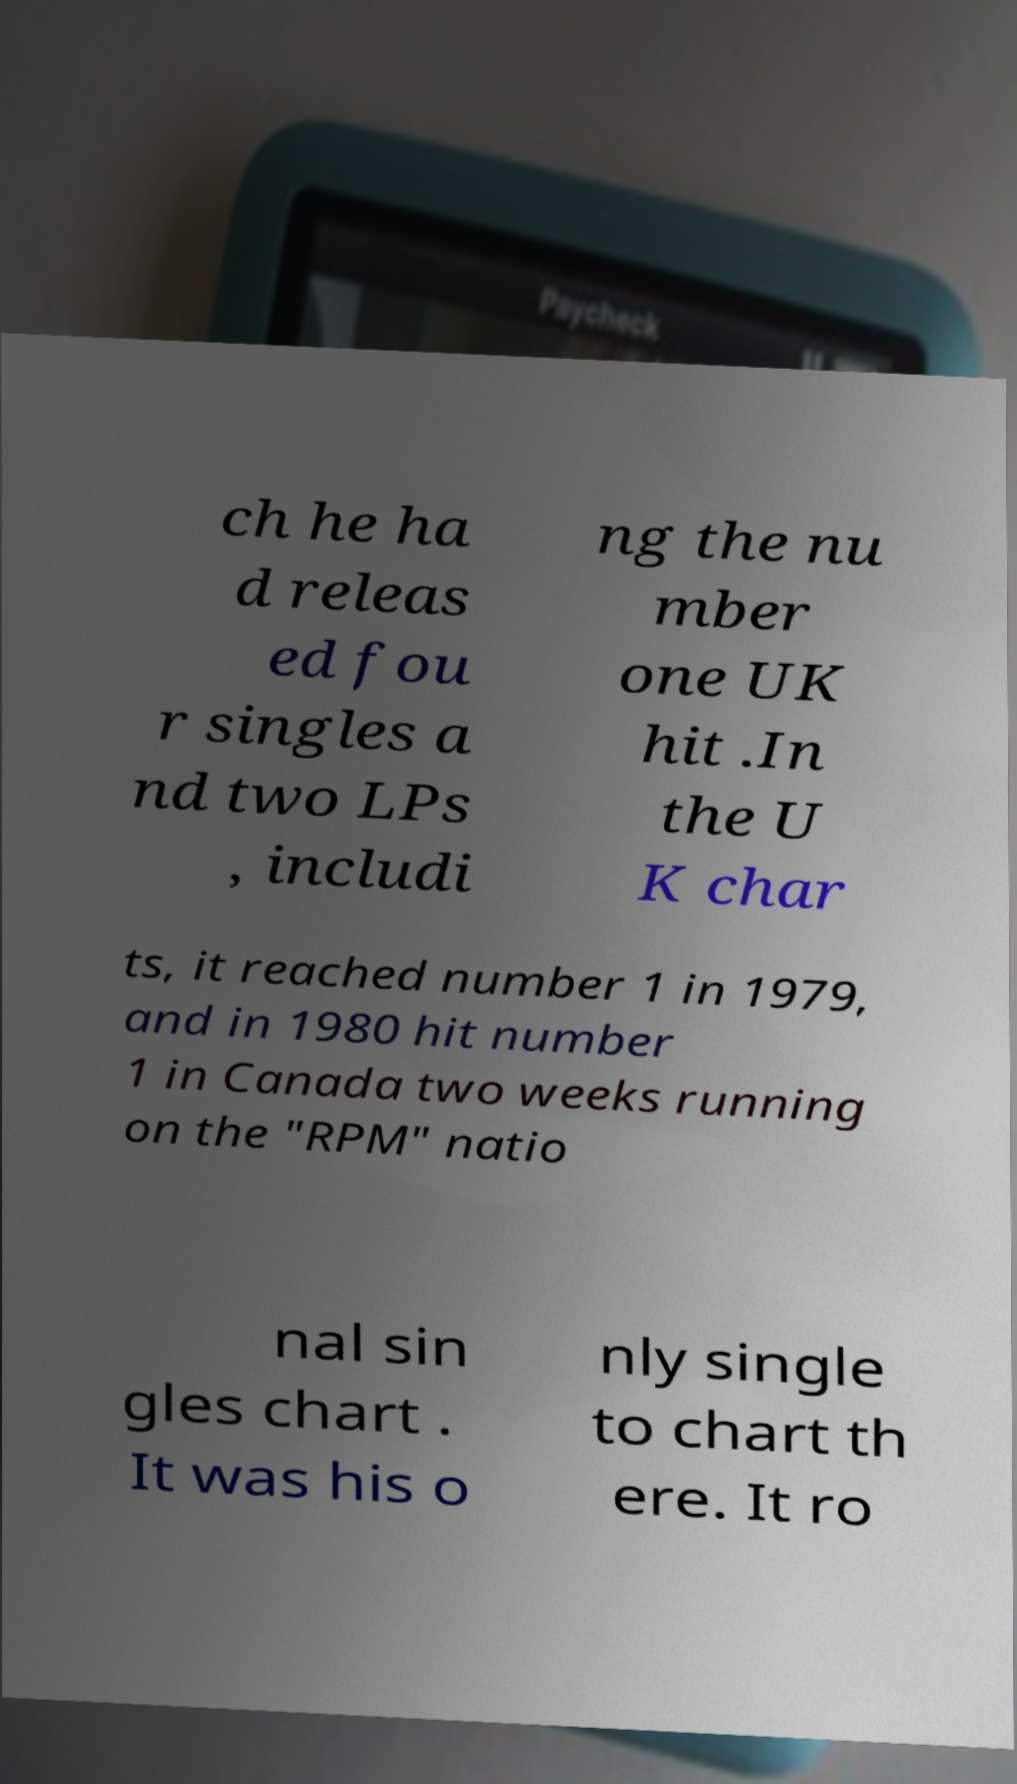Could you assist in decoding the text presented in this image and type it out clearly? ch he ha d releas ed fou r singles a nd two LPs , includi ng the nu mber one UK hit .In the U K char ts, it reached number 1 in 1979, and in 1980 hit number 1 in Canada two weeks running on the "RPM" natio nal sin gles chart . It was his o nly single to chart th ere. It ro 